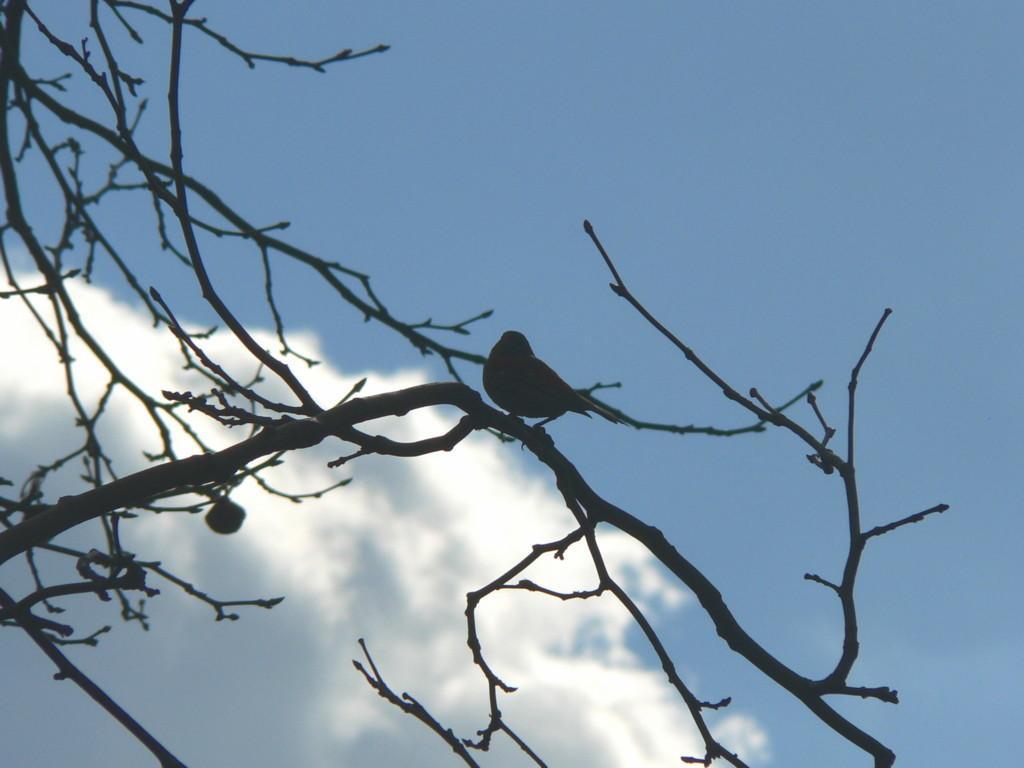Could you give a brief overview of what you see in this image? In this image we can see a bird sitting on the stems and we can also see the sky. 